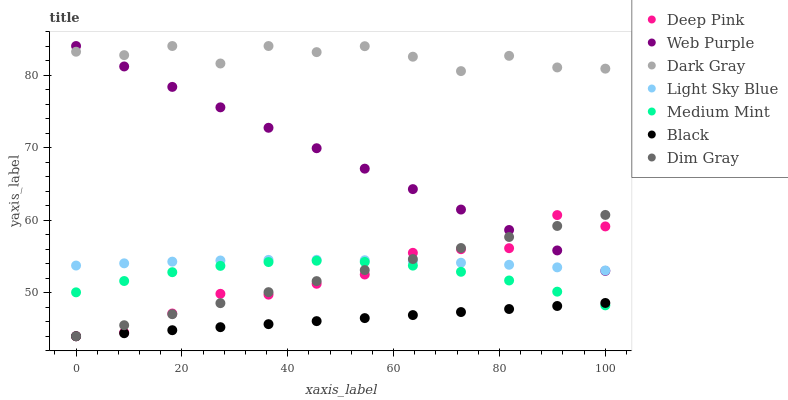Does Black have the minimum area under the curve?
Answer yes or no. Yes. Does Dark Gray have the maximum area under the curve?
Answer yes or no. Yes. Does Deep Pink have the minimum area under the curve?
Answer yes or no. No. Does Deep Pink have the maximum area under the curve?
Answer yes or no. No. Is Black the smoothest?
Answer yes or no. Yes. Is Dark Gray the roughest?
Answer yes or no. Yes. Is Deep Pink the smoothest?
Answer yes or no. No. Is Deep Pink the roughest?
Answer yes or no. No. Does Deep Pink have the lowest value?
Answer yes or no. Yes. Does Dark Gray have the lowest value?
Answer yes or no. No. Does Web Purple have the highest value?
Answer yes or no. Yes. Does Deep Pink have the highest value?
Answer yes or no. No. Is Medium Mint less than Dark Gray?
Answer yes or no. Yes. Is Light Sky Blue greater than Black?
Answer yes or no. Yes. Does Light Sky Blue intersect Deep Pink?
Answer yes or no. Yes. Is Light Sky Blue less than Deep Pink?
Answer yes or no. No. Is Light Sky Blue greater than Deep Pink?
Answer yes or no. No. Does Medium Mint intersect Dark Gray?
Answer yes or no. No. 